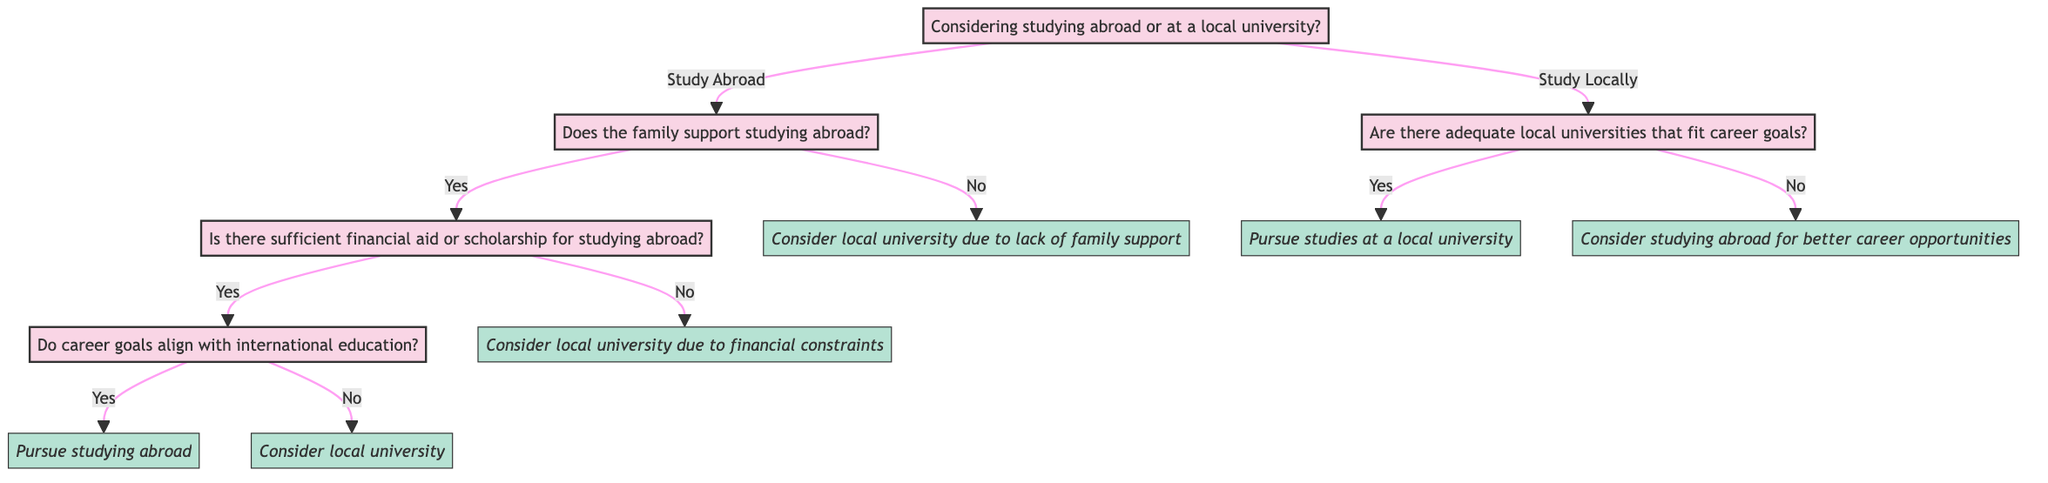What is the first question asked in the decision tree? The first question posed in the diagram is found at the root node, which is about whether to consider studying abroad or at a local university.
Answer: Considering studying abroad or at a local university? How many options are available when considering studying abroad? According to the options stemming from the node about studying abroad, there are two distinct paths: one for family support and one that leads to local university consideration.
Answer: Two options What happens if there is insufficient financial aid for studying abroad? Following the flow of the diagram, if the answer to financial aid availability is no, then the outcome is to consider a local university due to financial constraints.
Answer: Consider local university due to financial constraints What will be the outcome if family support is not present? The diagram indicates that if the family does not support studying abroad, the outcome is to consider a local university.
Answer: Consider local university due to lack of family support If the decision is to study locally, what is the next question asked? After deciding to study locally, the next question arises regarding whether there are adequate local universities that fit career goals.
Answer: Are there adequate local universities that fit career goals? What are the potential outcomes from the local university decision node? The outcomes stemming from the local university node depend on whether there are adequate local universities that fit career goals; if yes, it is to pursue local studies, and if no, it leads to considering studying abroad for better career opportunities.
Answer: Pursue studies at a local university, Consider studying abroad for better career opportunities What indicates a positive decision towards studying abroad? A positive decision towards studying abroad is indicated when there is family support, sufficient financial aid, and alignment of career goals with international education.
Answer: Pursue studying abroad What node leads to considering studying abroad for better career opportunities? The node that leads to considering studying abroad for better career opportunities occurs when there are no adequate local universities that fit career goals.
Answer: Consider studying abroad for better career opportunities 